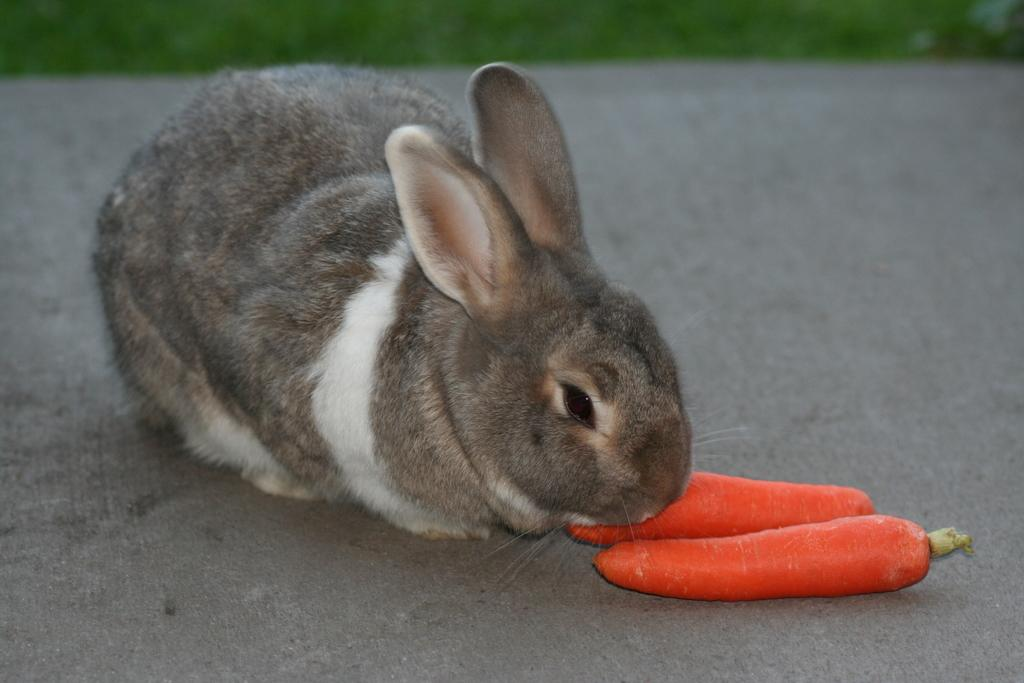What is the main subject in the center of the image? There is a rabbit in the center of the image. What is in front of the rabbit? There are two carrots in front of the rabbit. What type of environment is visible at the top side of the image? There is grassland at the top side of the image. Are there any fairies visible in the image? There are no fairies present in the image. What type of weather condition is depicted in the image, such as sleet? The image does not depict any specific weather condition, including sleet. 